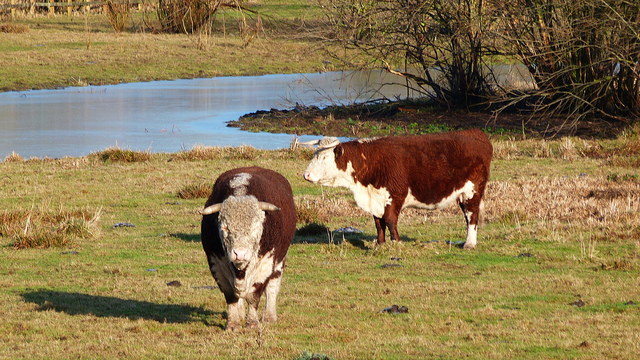What time of day does this scene seem to depict? The long shadows and the warm, golden light suggest this scene is most likely set in the late afternoon, a time of day often referred to as the 'golden hour' in photography due to the soft, diffused light. 